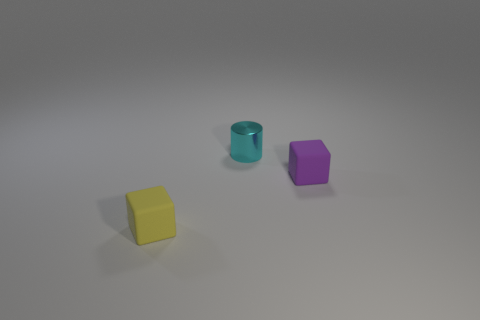Add 1 large blue shiny cylinders. How many objects exist? 4 Subtract all blocks. How many objects are left? 1 Add 2 big brown rubber cylinders. How many big brown rubber cylinders exist? 2 Subtract 1 purple cubes. How many objects are left? 2 Subtract all cyan objects. Subtract all big gray shiny balls. How many objects are left? 2 Add 1 purple cubes. How many purple cubes are left? 2 